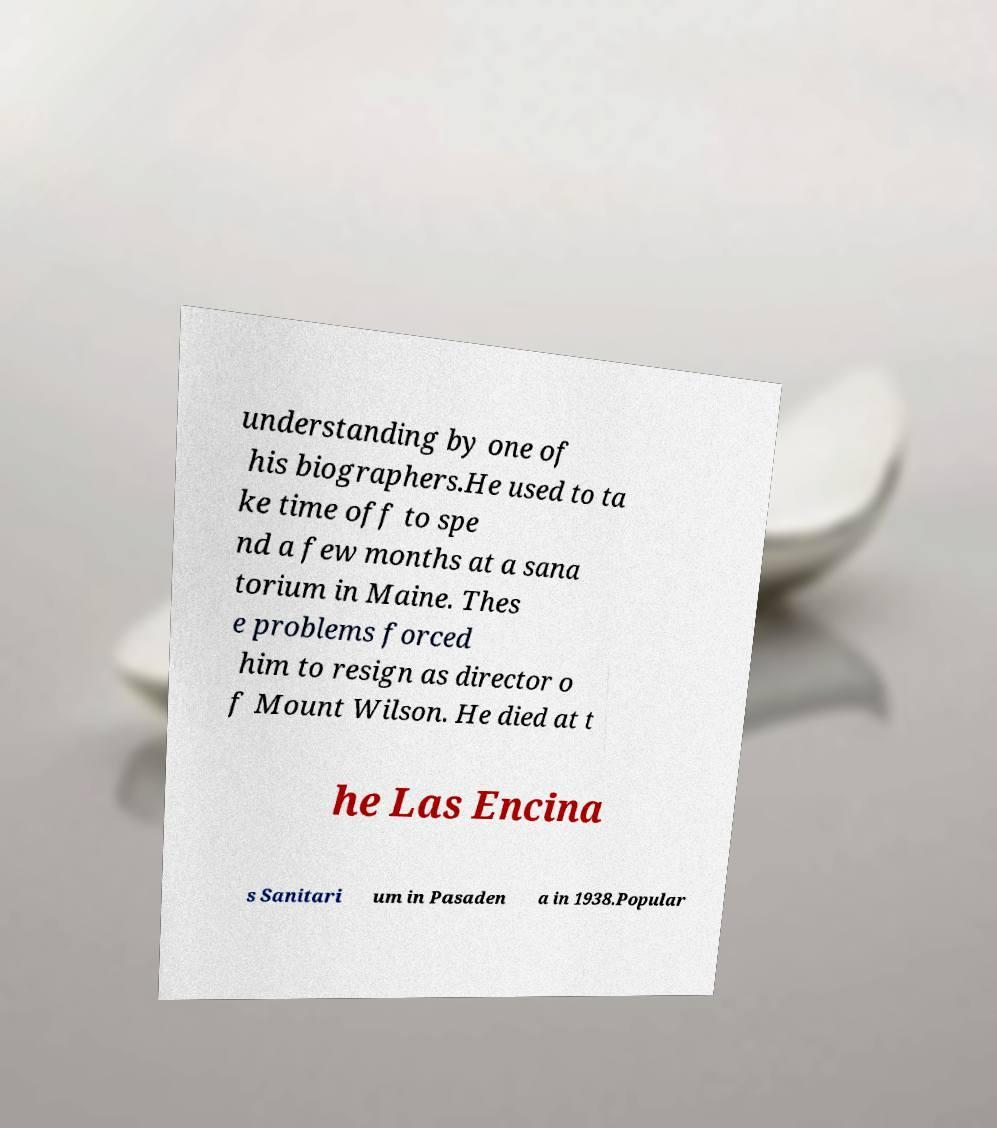Could you assist in decoding the text presented in this image and type it out clearly? understanding by one of his biographers.He used to ta ke time off to spe nd a few months at a sana torium in Maine. Thes e problems forced him to resign as director o f Mount Wilson. He died at t he Las Encina s Sanitari um in Pasaden a in 1938.Popular 